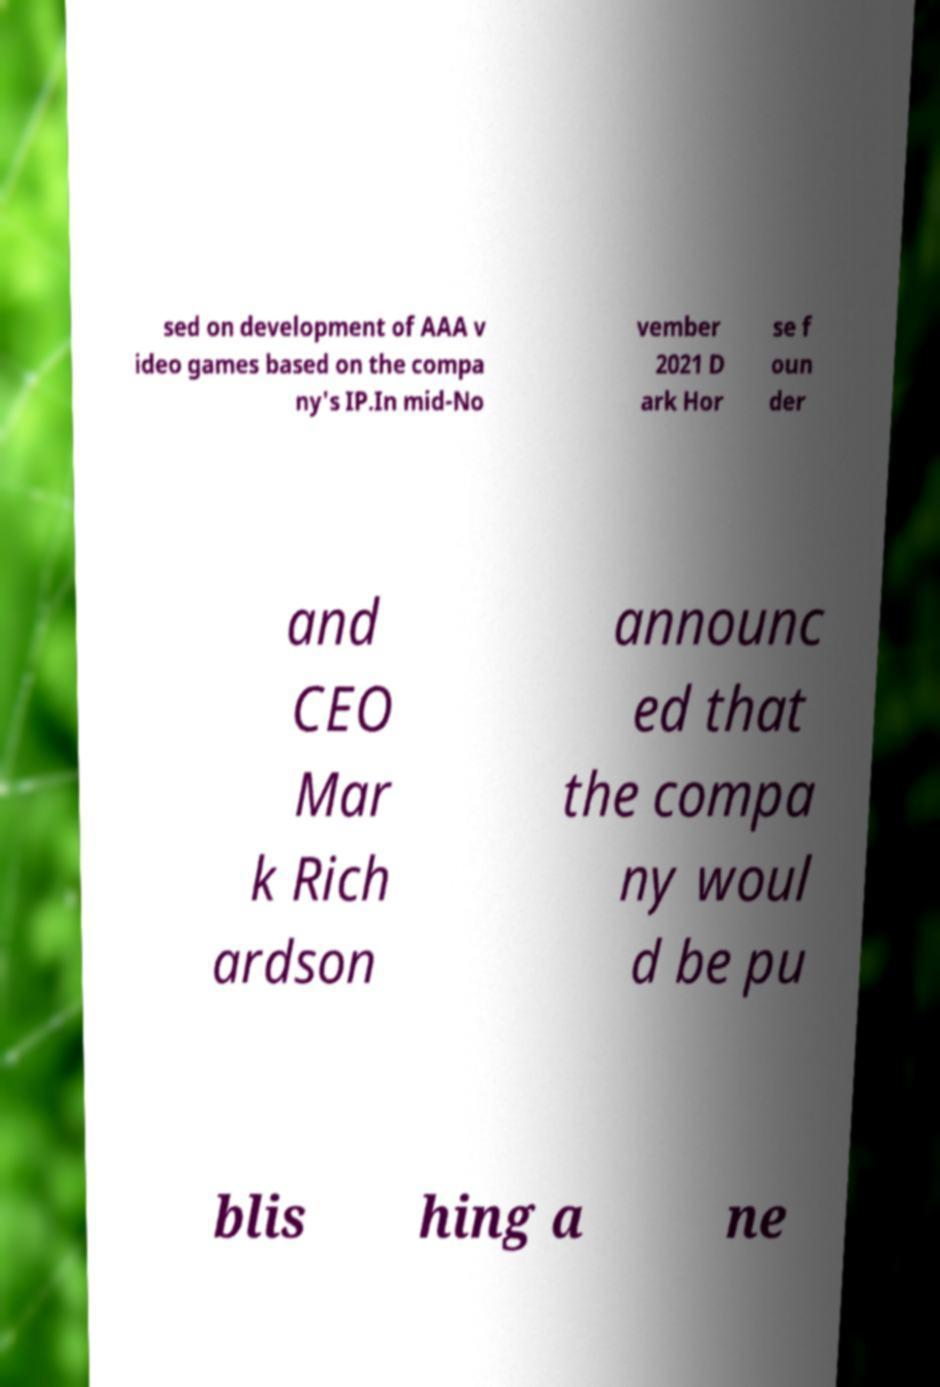There's text embedded in this image that I need extracted. Can you transcribe it verbatim? sed on development of AAA v ideo games based on the compa ny's IP.In mid-No vember 2021 D ark Hor se f oun der and CEO Mar k Rich ardson announc ed that the compa ny woul d be pu blis hing a ne 